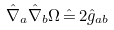<formula> <loc_0><loc_0><loc_500><loc_500>\hat { \nabla } _ { a } \hat { \nabla } _ { b } \Omega \, \hat { = } \, 2 \hat { g } _ { a b }</formula> 